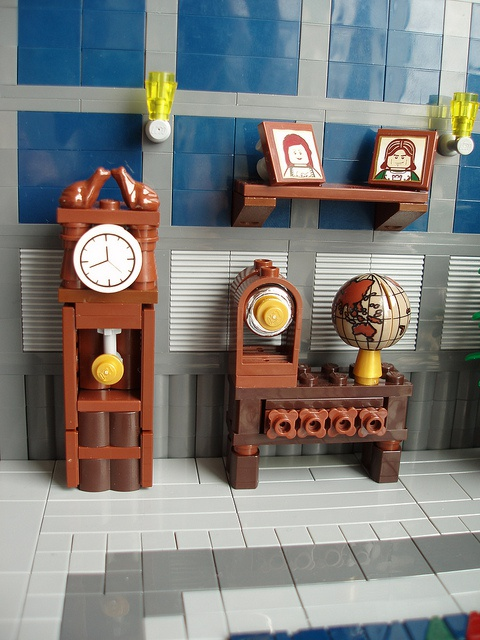Describe the objects in this image and their specific colors. I can see a clock in gray, white, maroon, and brown tones in this image. 